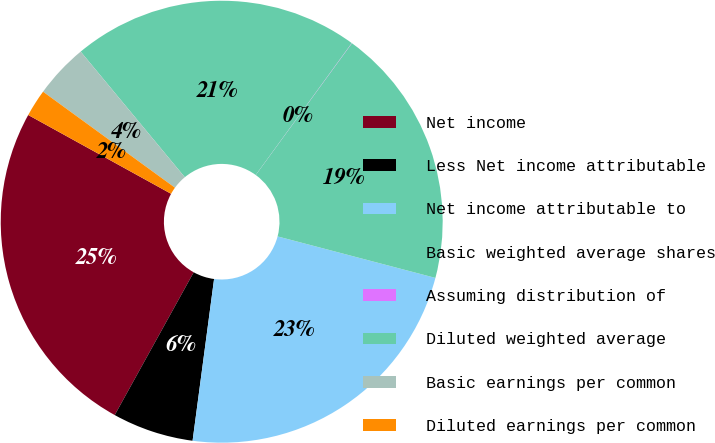<chart> <loc_0><loc_0><loc_500><loc_500><pie_chart><fcel>Net income<fcel>Less Net income attributable<fcel>Net income attributable to<fcel>Basic weighted average shares<fcel>Assuming distribution of<fcel>Diluted weighted average<fcel>Basic earnings per common<fcel>Diluted earnings per common<nl><fcel>24.98%<fcel>5.94%<fcel>23.01%<fcel>19.06%<fcel>0.02%<fcel>21.03%<fcel>3.97%<fcel>1.99%<nl></chart> 